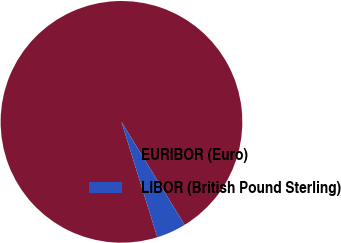Convert chart. <chart><loc_0><loc_0><loc_500><loc_500><pie_chart><fcel>EURIBOR (Euro)<fcel>LIBOR (British Pound Sterling)<nl><fcel>96.04%<fcel>3.96%<nl></chart> 